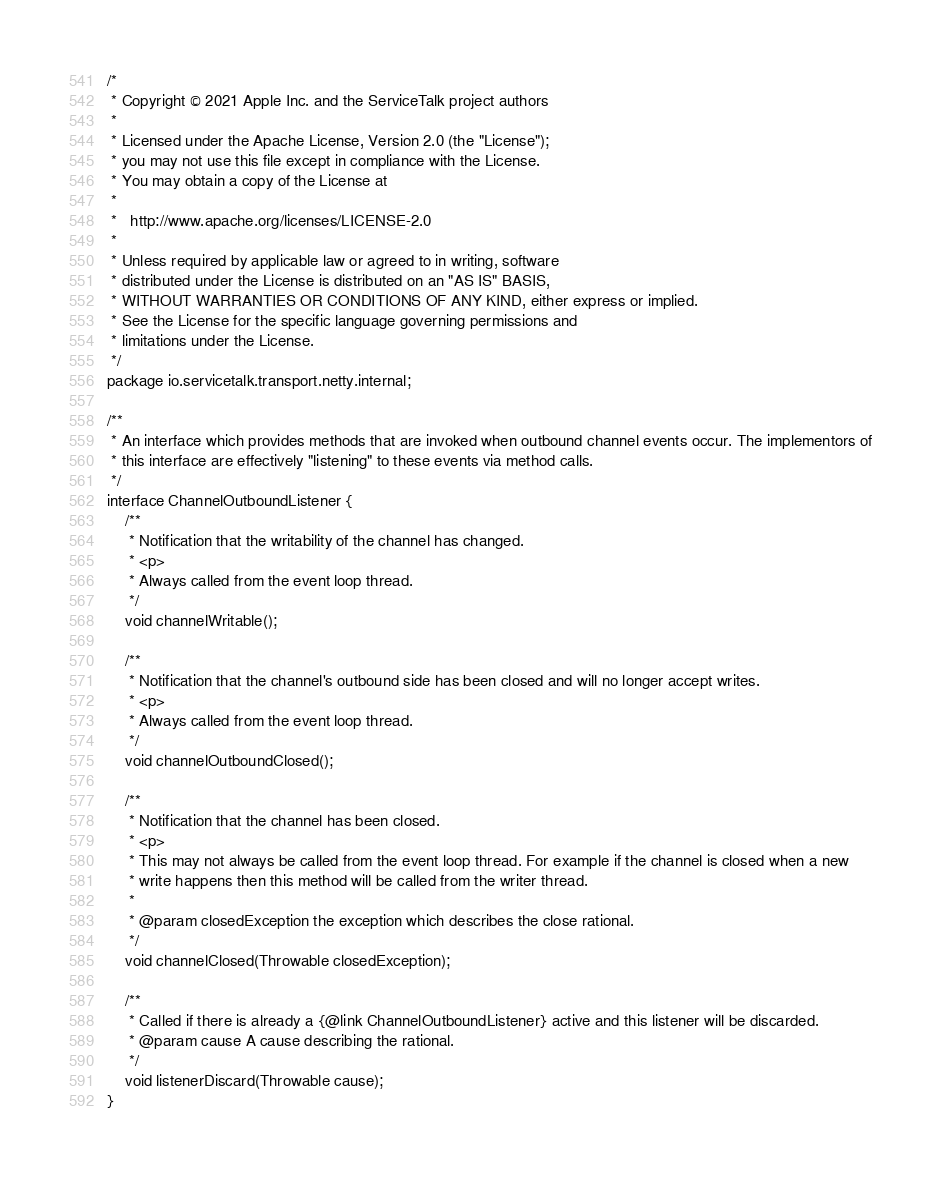Convert code to text. <code><loc_0><loc_0><loc_500><loc_500><_Java_>/*
 * Copyright © 2021 Apple Inc. and the ServiceTalk project authors
 *
 * Licensed under the Apache License, Version 2.0 (the "License");
 * you may not use this file except in compliance with the License.
 * You may obtain a copy of the License at
 *
 *   http://www.apache.org/licenses/LICENSE-2.0
 *
 * Unless required by applicable law or agreed to in writing, software
 * distributed under the License is distributed on an "AS IS" BASIS,
 * WITHOUT WARRANTIES OR CONDITIONS OF ANY KIND, either express or implied.
 * See the License for the specific language governing permissions and
 * limitations under the License.
 */
package io.servicetalk.transport.netty.internal;

/**
 * An interface which provides methods that are invoked when outbound channel events occur. The implementors of
 * this interface are effectively "listening" to these events via method calls.
 */
interface ChannelOutboundListener {
    /**
     * Notification that the writability of the channel has changed.
     * <p>
     * Always called from the event loop thread.
     */
    void channelWritable();

    /**
     * Notification that the channel's outbound side has been closed and will no longer accept writes.
     * <p>
     * Always called from the event loop thread.
     */
    void channelOutboundClosed();

    /**
     * Notification that the channel has been closed.
     * <p>
     * This may not always be called from the event loop thread. For example if the channel is closed when a new
     * write happens then this method will be called from the writer thread.
     *
     * @param closedException the exception which describes the close rational.
     */
    void channelClosed(Throwable closedException);

    /**
     * Called if there is already a {@link ChannelOutboundListener} active and this listener will be discarded.
     * @param cause A cause describing the rational.
     */
    void listenerDiscard(Throwable cause);
}
</code> 